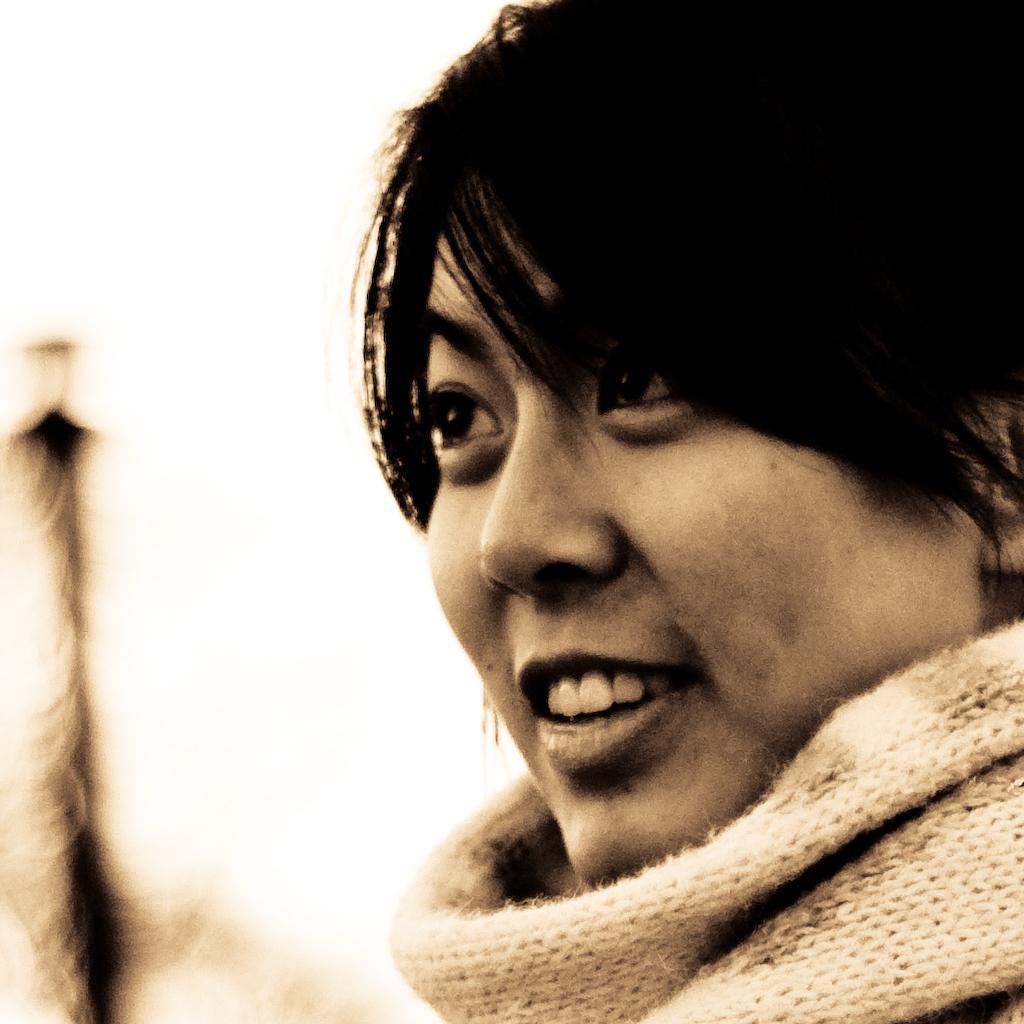Describe this image in one or two sentences. In this image we can see one person. And the background is blurred. 